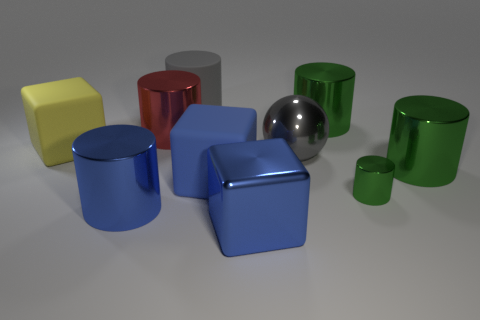There is a large cylinder that is the same color as the large metallic cube; what material is it?
Your response must be concise. Metal. The red metallic thing that is the same size as the gray metal object is what shape?
Your answer should be very brief. Cylinder. Is there a blue shiny object that has the same shape as the red metal thing?
Your response must be concise. Yes. Is the material of the tiny green thing the same as the large gray object behind the large red metallic object?
Ensure brevity in your answer.  No. Is there another large metallic sphere that has the same color as the big metallic ball?
Give a very brief answer. No. What number of other objects are there of the same material as the small green object?
Offer a very short reply. 6. Does the big ball have the same color as the rubber object behind the red cylinder?
Offer a very short reply. Yes. Are there more big yellow cubes that are behind the yellow matte block than purple rubber cylinders?
Your response must be concise. No. How many blue metallic objects are left of the blue cube that is in front of the rubber object in front of the large gray ball?
Keep it short and to the point. 1. Do the big metal thing that is to the left of the red cylinder and the large blue matte object have the same shape?
Offer a terse response. No. 